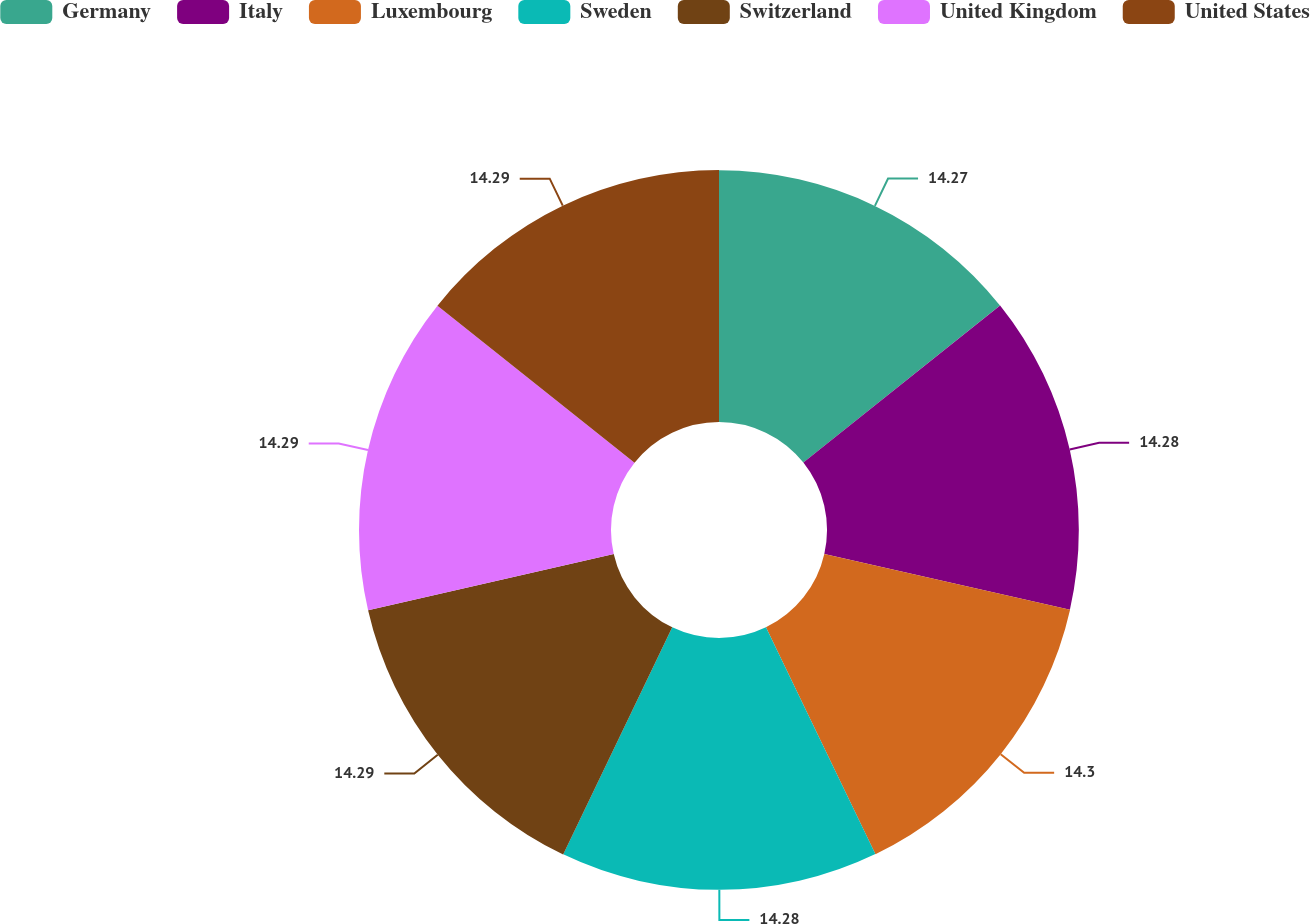<chart> <loc_0><loc_0><loc_500><loc_500><pie_chart><fcel>Germany<fcel>Italy<fcel>Luxembourg<fcel>Sweden<fcel>Switzerland<fcel>United Kingdom<fcel>United States<nl><fcel>14.27%<fcel>14.28%<fcel>14.29%<fcel>14.28%<fcel>14.29%<fcel>14.29%<fcel>14.29%<nl></chart> 